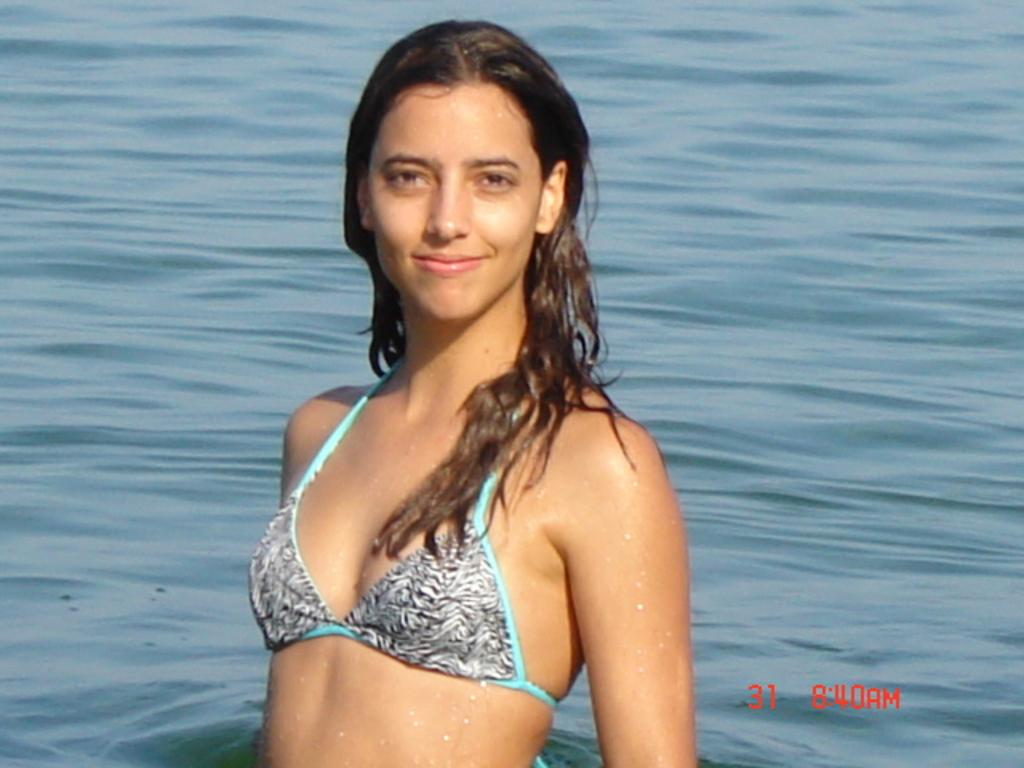Who is present in the image? There is a woman in the image. What is the woman doing in the image? The woman is in the water. What is the woman wearing in the image? The woman is wearing a bikini with white, black, and light blue colors. Is there any additional information about the image? Yes, there is a watermark in the image. How many friends is the woman coaching in the image? There are no friends or coaching activities depicted in the image. 